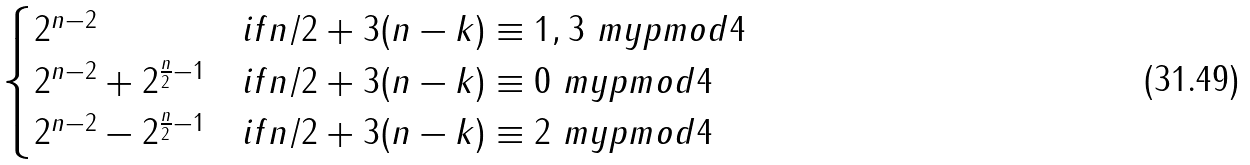Convert formula to latex. <formula><loc_0><loc_0><loc_500><loc_500>\begin{cases} 2 ^ { n - 2 } & i f n / 2 + 3 ( n - k ) \equiv 1 , 3 \ m y p m o d 4 \\ 2 ^ { n - 2 } + 2 ^ { \frac { n } { 2 } - 1 } & i f n / 2 + 3 ( n - k ) \equiv 0 \ m y p m o d 4 \\ 2 ^ { n - 2 } - 2 ^ { \frac { n } { 2 } - 1 } & i f n / 2 + 3 ( n - k ) \equiv 2 \ m y p m o d 4 \end{cases}</formula> 